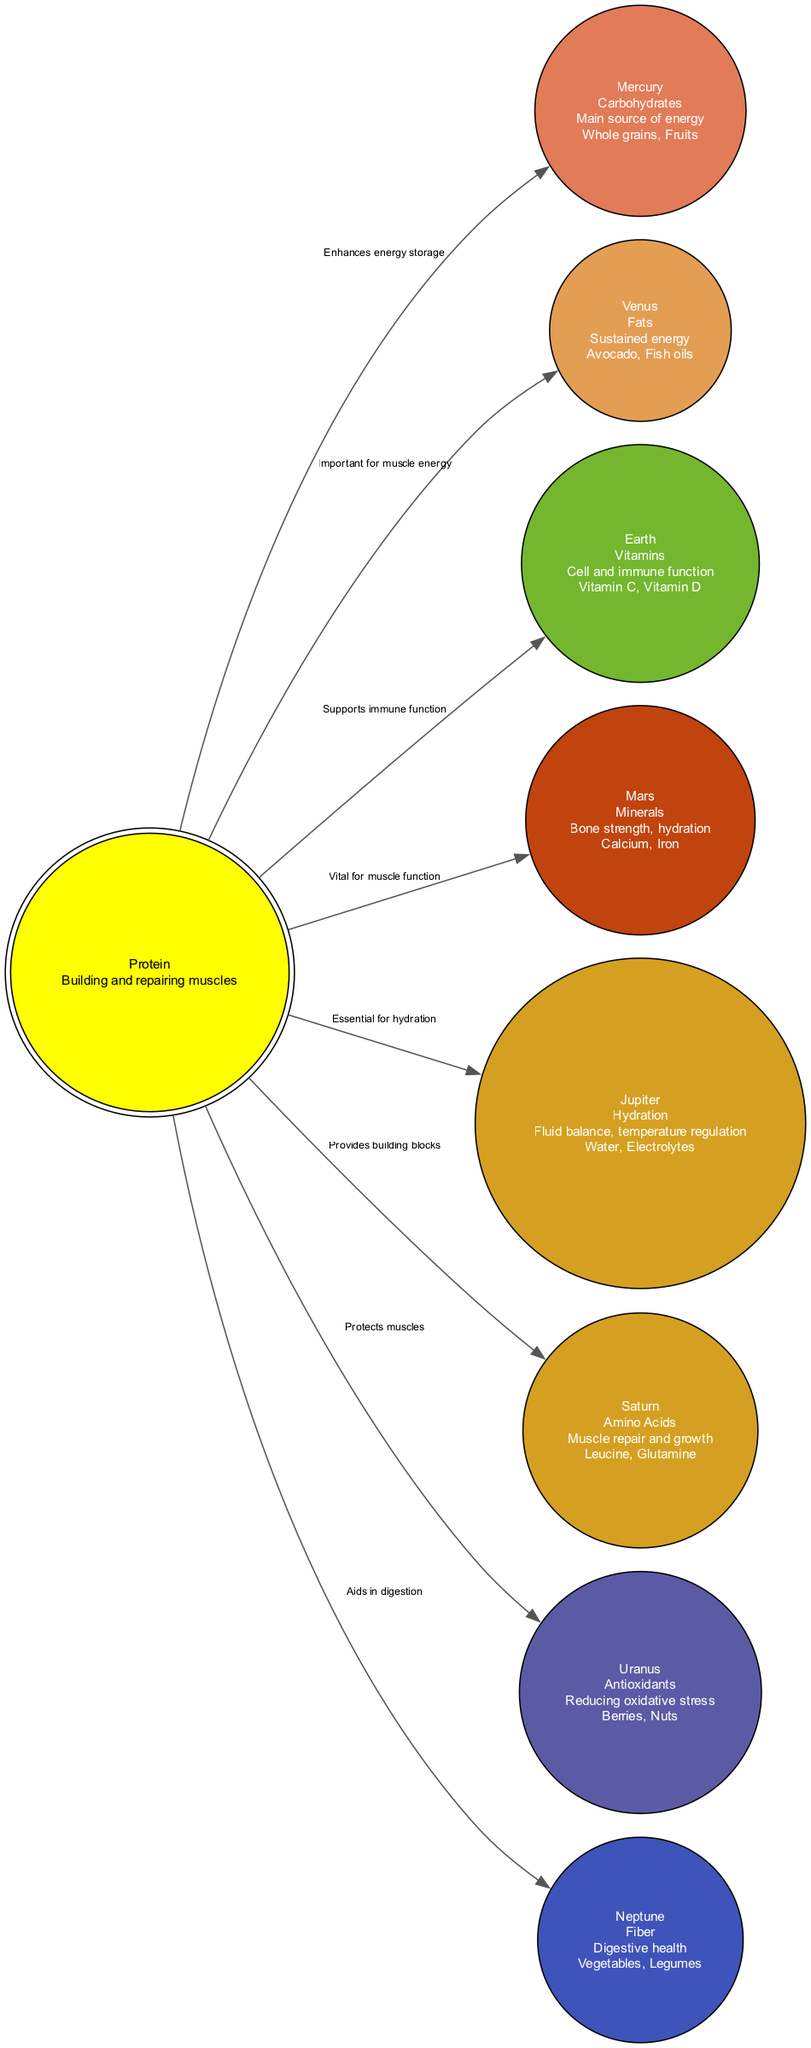What nutrient is represented by the Sun? The Sun represents Protein, which is indicated at the center of the diagram along with its description of "Building and repairing muscles."
Answer: Protein How many planets are there in the diagram? The diagram lists 8 planets plus the Sun, so when counted together, there are 9 nodes.
Answer: 8 What is the benefit of Carbohydrates? Carbohydrates are indicated to be the "Main source of energy," as described on the Mercury node of the diagram.
Answer: Main source of energy Which nutrient aids in reducing oxidative stress? The diagram shows that Antioxidants, represented by Uranus, are responsible for reducing oxidative stress.
Answer: Antioxidants Which nutrient is essential for hydration? Jupiter is indicated in the diagram as the nutrient crucial for hydration, with a specific mention of "Fluid balance, temperature regulation."
Answer: Hydration What nutrient is important for muscle repair and growth? Amino Acids, located at Saturn, are noted in the diagram as the nutrient important for muscle repair and growth.
Answer: Amino Acids What nutrient promotes digestive health? The diagram specifies that Fiber, represented by Neptune, is the nutrient that aids in digestive health.
Answer: Fiber How does the Sun influence the planets? The edges from the Sun to each planet in the diagram describe different supportive roles, such as "Enhances energy storage" and "Provides building blocks," which suggest a direct influence of Protein on each nutrient.
Answer: Via edges with descriptive roles What are the examples given for Vitamins? The Earth node contains examples of Vitamins as "Vitamin C" and "Vitamin D," which are detailed in the label of that node.
Answer: Vitamin C, Vitamin D 